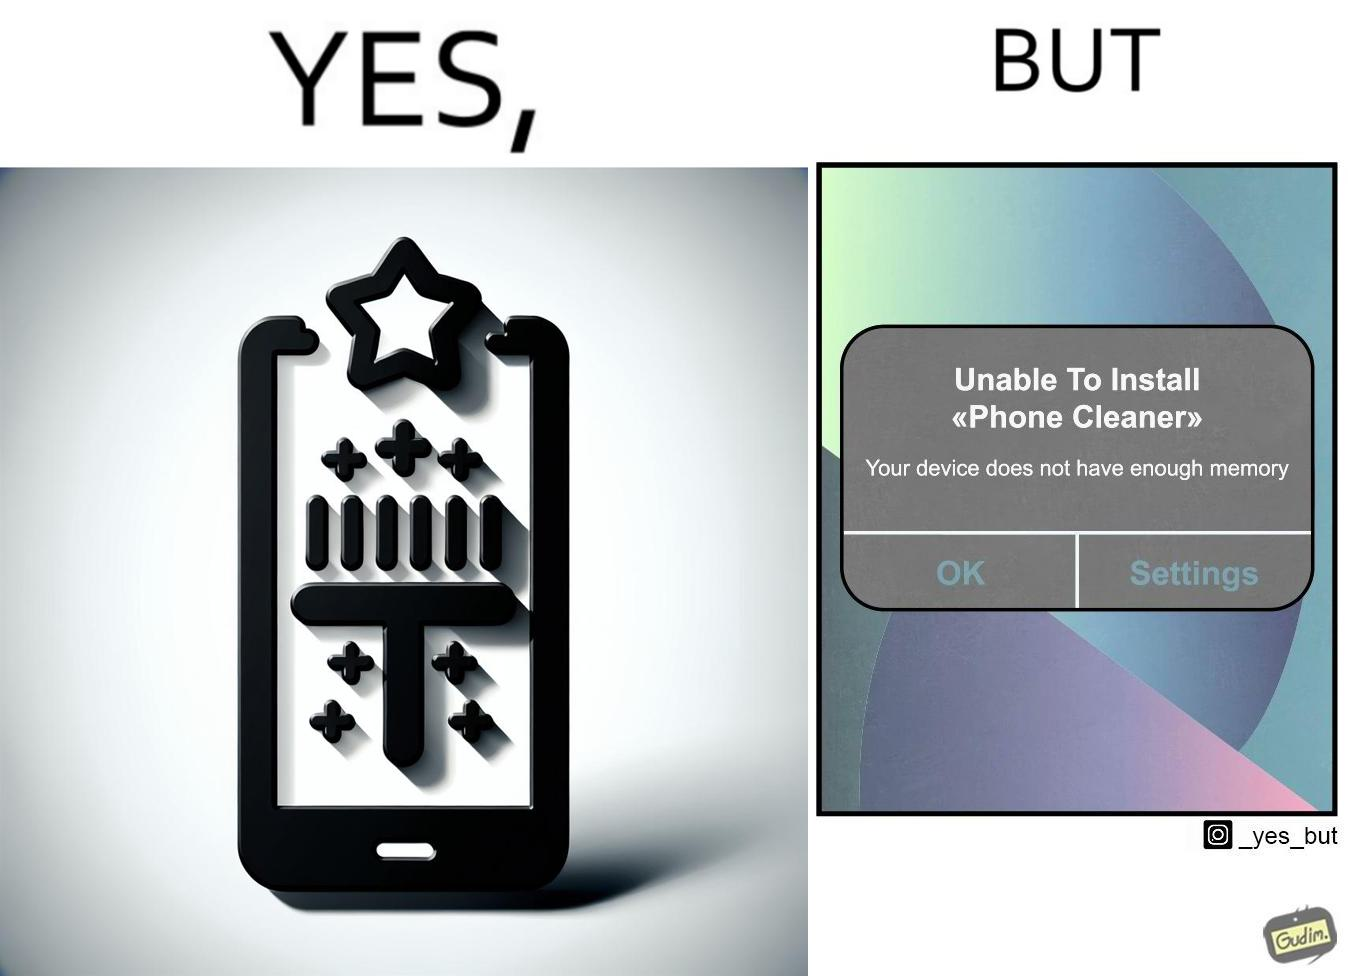Describe what you see in this image. The image is ironical, as to clear the phone's memory using phone cleaner app, one has to install it, but that is not possible in turn due to the phone memory being full. 